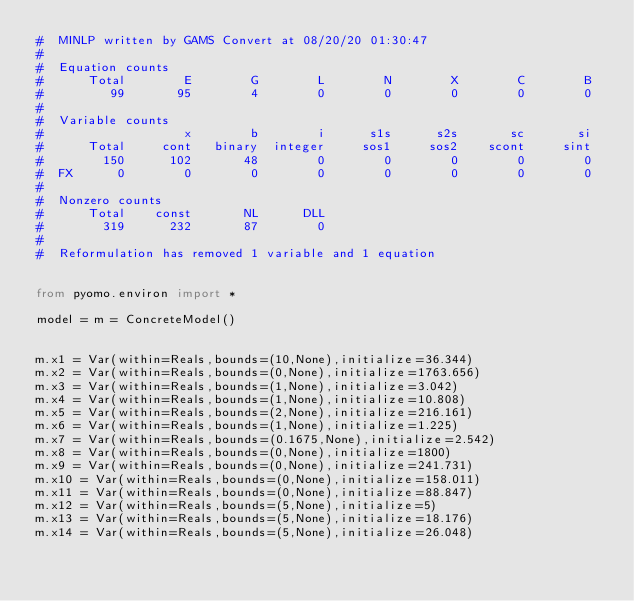Convert code to text. <code><loc_0><loc_0><loc_500><loc_500><_Python_>#  MINLP written by GAMS Convert at 08/20/20 01:30:47
#  
#  Equation counts
#      Total        E        G        L        N        X        C        B
#         99       95        4        0        0        0        0        0
#  
#  Variable counts
#                   x        b        i      s1s      s2s       sc       si
#      Total     cont   binary  integer     sos1     sos2    scont     sint
#        150      102       48        0        0        0        0        0
#  FX      0        0        0        0        0        0        0        0
#  
#  Nonzero counts
#      Total    const       NL      DLL
#        319      232       87        0
# 
#  Reformulation has removed 1 variable and 1 equation


from pyomo.environ import *

model = m = ConcreteModel()


m.x1 = Var(within=Reals,bounds=(10,None),initialize=36.344)
m.x2 = Var(within=Reals,bounds=(0,None),initialize=1763.656)
m.x3 = Var(within=Reals,bounds=(1,None),initialize=3.042)
m.x4 = Var(within=Reals,bounds=(1,None),initialize=10.808)
m.x5 = Var(within=Reals,bounds=(2,None),initialize=216.161)
m.x6 = Var(within=Reals,bounds=(1,None),initialize=1.225)
m.x7 = Var(within=Reals,bounds=(0.1675,None),initialize=2.542)
m.x8 = Var(within=Reals,bounds=(0,None),initialize=1800)
m.x9 = Var(within=Reals,bounds=(0,None),initialize=241.731)
m.x10 = Var(within=Reals,bounds=(0,None),initialize=158.011)
m.x11 = Var(within=Reals,bounds=(0,None),initialize=88.847)
m.x12 = Var(within=Reals,bounds=(5,None),initialize=5)
m.x13 = Var(within=Reals,bounds=(5,None),initialize=18.176)
m.x14 = Var(within=Reals,bounds=(5,None),initialize=26.048)</code> 